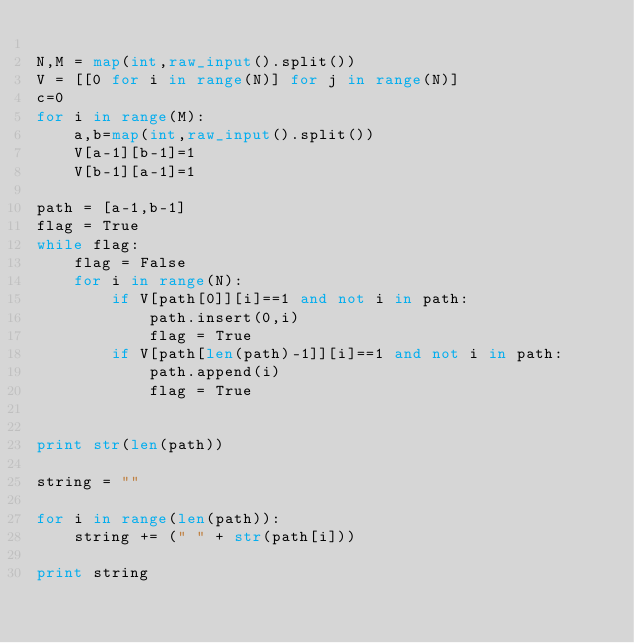<code> <loc_0><loc_0><loc_500><loc_500><_Python_>
N,M = map(int,raw_input().split())
V = [[0 for i in range(N)] for j in range(N)]
c=0
for i in range(M):
    a,b=map(int,raw_input().split())
    V[a-1][b-1]=1
    V[b-1][a-1]=1

path = [a-1,b-1]
flag = True
while flag:
    flag = False
    for i in range(N):
        if V[path[0]][i]==1 and not i in path:
            path.insert(0,i)
            flag = True
        if V[path[len(path)-1]][i]==1 and not i in path:
            path.append(i)
            flag = True
    

print str(len(path))

string = ""

for i in range(len(path)):
    string += (" " + str(path[i]))

print string</code> 